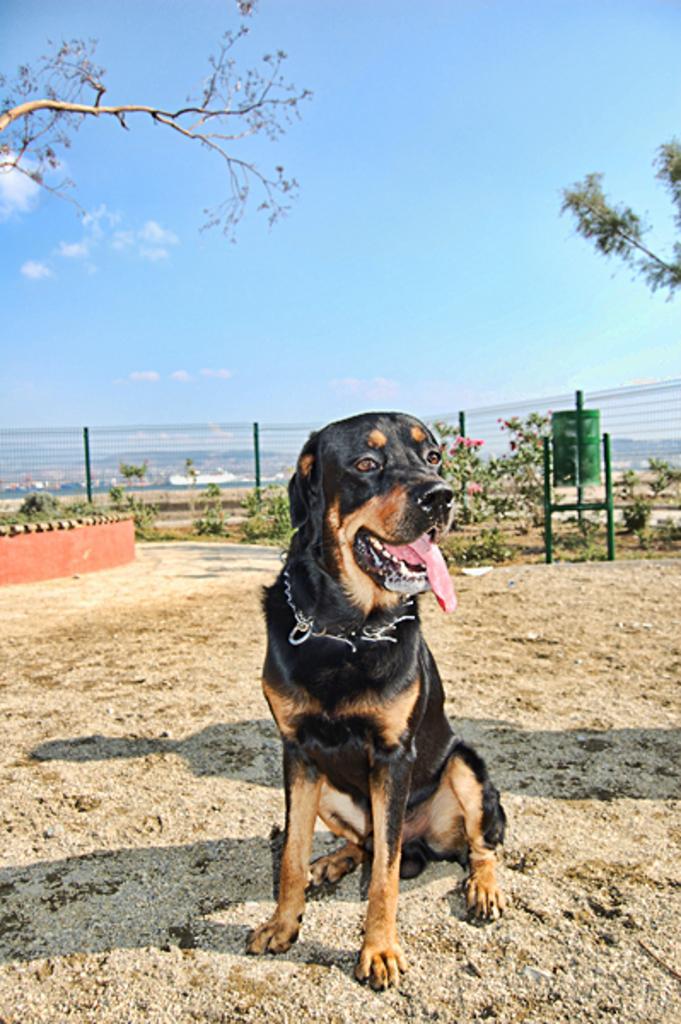Could you give a brief overview of what you see in this image? In this image I see a dog which is of black and brown in color and I see the ground. In the background I see the plants and I see a green color bin on these roads and I see the trees and I see the clear sky. 